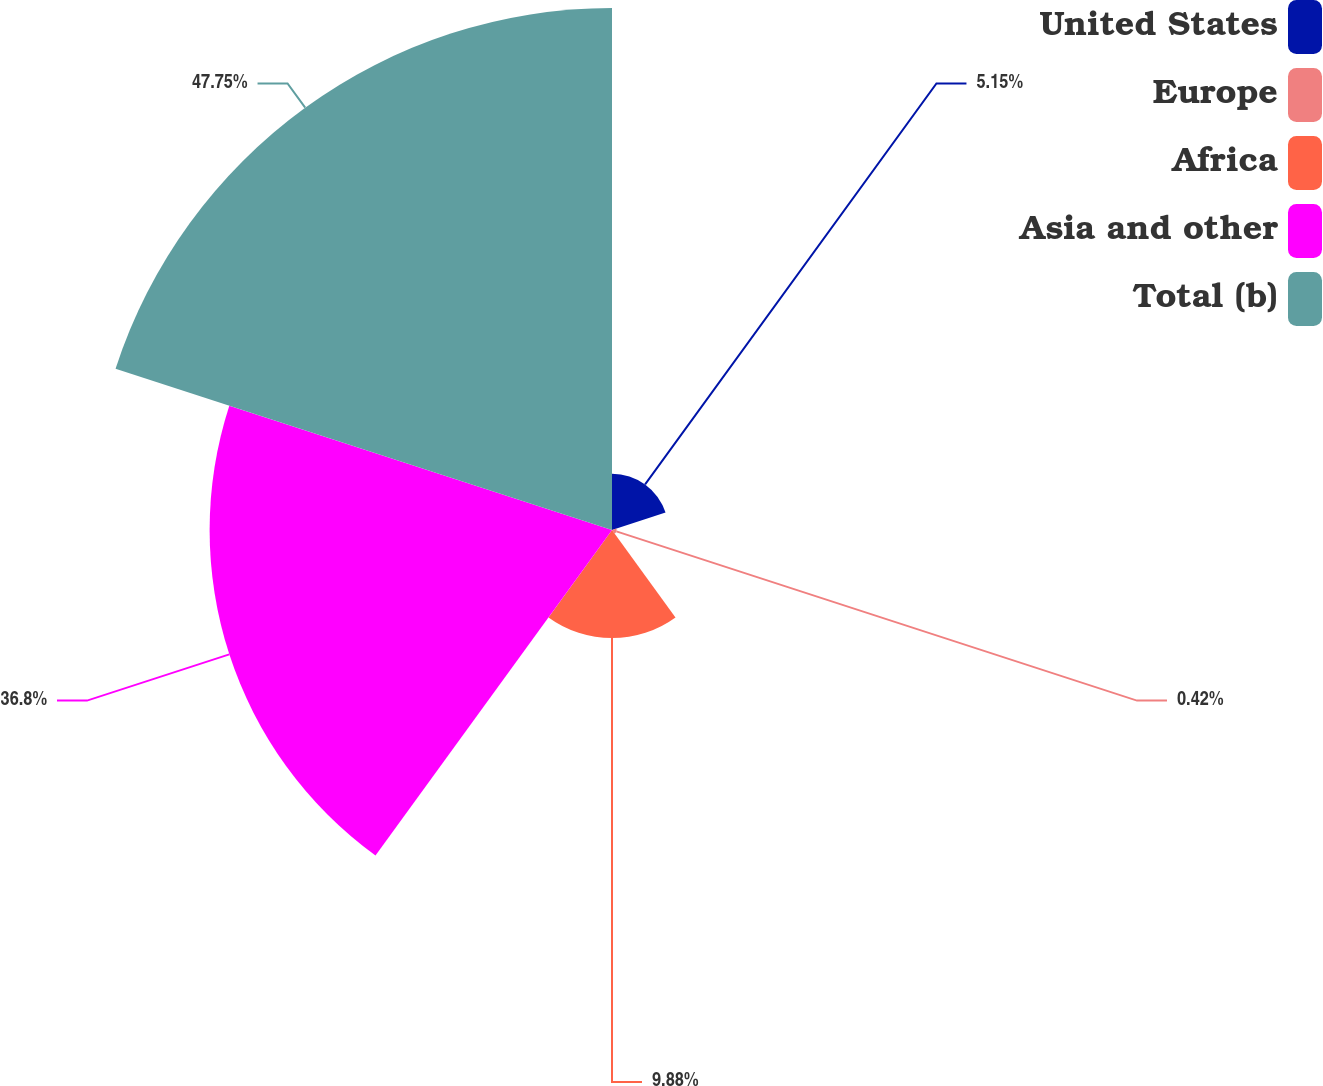Convert chart to OTSL. <chart><loc_0><loc_0><loc_500><loc_500><pie_chart><fcel>United States<fcel>Europe<fcel>Africa<fcel>Asia and other<fcel>Total (b)<nl><fcel>5.15%<fcel>0.42%<fcel>9.88%<fcel>36.8%<fcel>47.74%<nl></chart> 